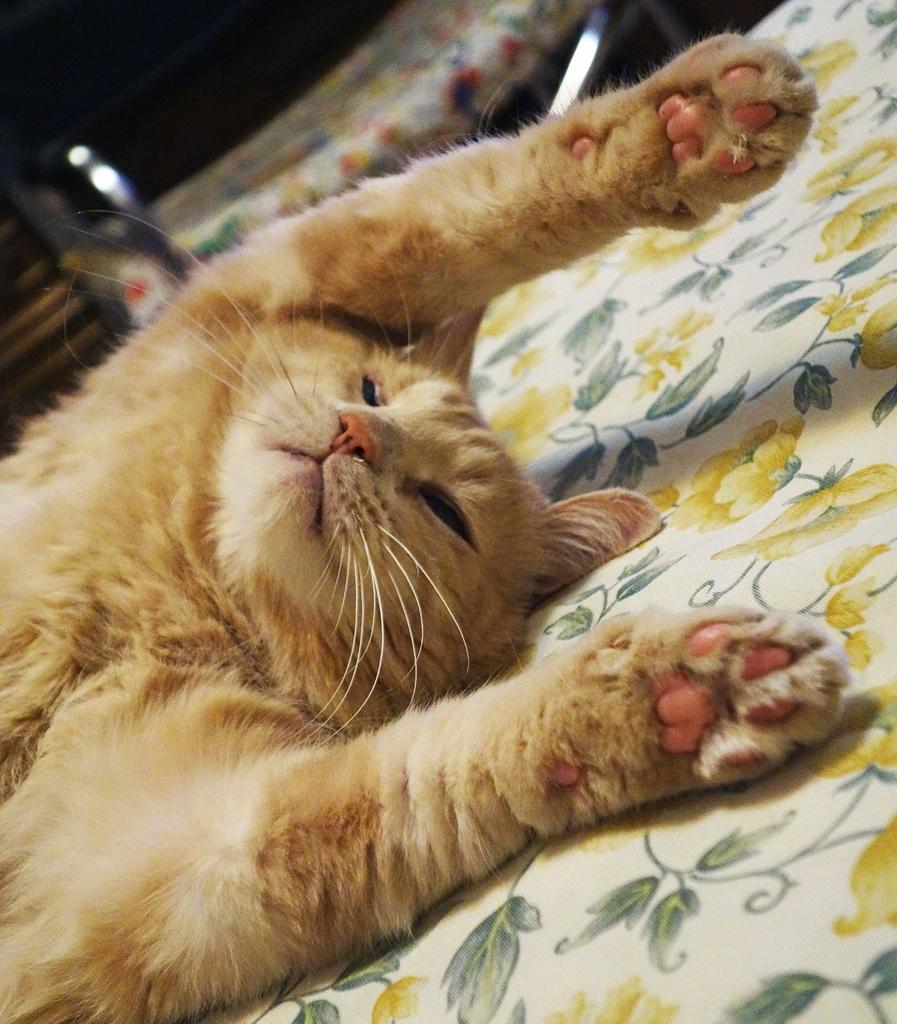What type of animal is present in the image? There is a brown-colored cat in the image. What is the cat lying on in the image? The cat is lying on a yellow-colored flower bed sheet. What type of lipstick is the cat wearing in the image? There is no lipstick or any indication of the cat wearing lipstick in the image. What is the weight of the cat in the image? The weight of the cat cannot be determined from the image alone. 